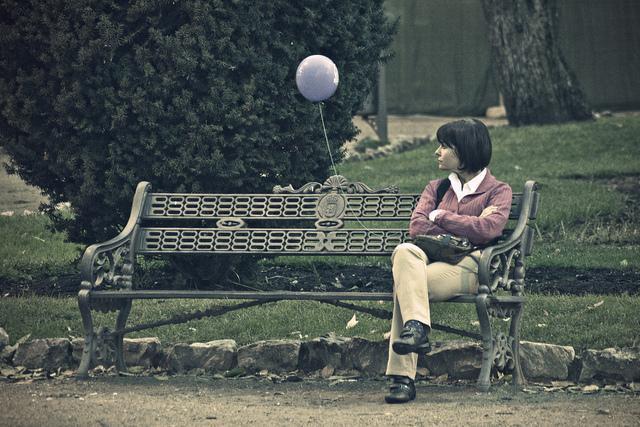How many people are sitting on the bench?
Give a very brief answer. 1. How many benches are visible?
Give a very brief answer. 1. 